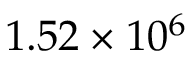<formula> <loc_0><loc_0><loc_500><loc_500>1 . 5 2 \times 1 0 ^ { 6 }</formula> 